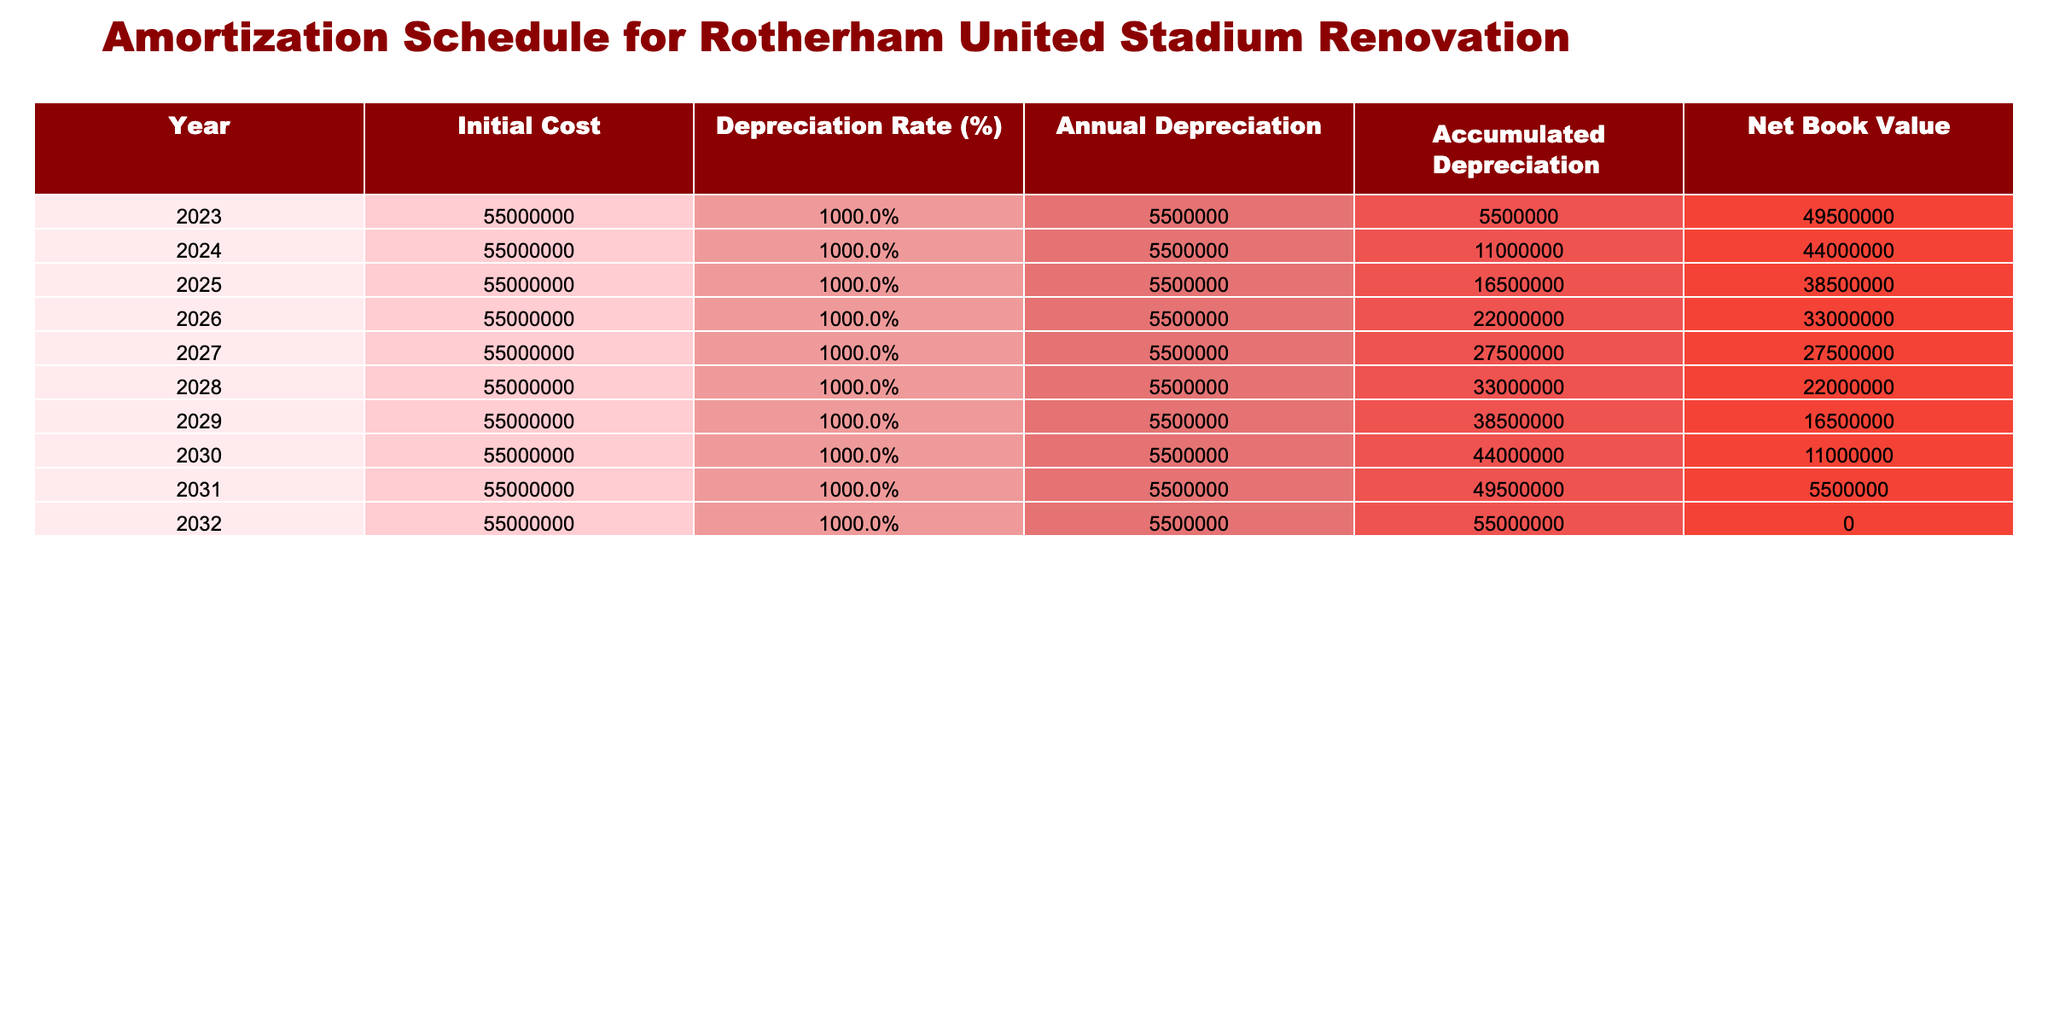What is the initial cost of the stadium renovation? The initial cost is specified in the first row of the table under "Initial Cost," which states £55,000,000.
Answer: £55,000,000 What is the accumulated depreciation in 2026? Looking at the "Accumulated Depreciation" column for the year 2026, the value listed is £22,000,000.
Answer: £22,000,000 In which year does the net book value of the stadium reach zero? The "Net Book Value" reaches zero in the year 2032, as seen in the last row of the table where it displays £0.
Answer: 2032 What is the total annual depreciation over the 10 years? To find the total annual depreciation, we sum the annual depreciation amounts for each year, which are all £5,500,000, resulting in £5,500,000 * 10 = £55,000,000.
Answer: £55,000,000 Is the annual depreciation consistent throughout the years? Yes, the annual depreciation is consistently £5,500,000 across all years.
Answer: Yes What is the net book value in 2028 compared to 2022? To determine this, we check the net book value for 2022, which is not explicitly listed but we can infer it is the same as the initial cost at £55,000,000. The net book value in 2028 is £22,000,000. Thus, it decreased from £55,000,000 to £22,000,000, which is a reduction of £33,000,000.
Answer: £22,000,000 What was the accumulated depreciation in 2025, and how much more was it in 2026? The accumulated depreciation in 2025 is £16,500,000, and in 2026, it is £22,000,000. The difference is £22,000,000 - £16,500,000 = £5,500,000.
Answer: £5,500,000 What percentage of the initial cost is the accumulated depreciation in 2030? The accumulated depreciation in 2030 is £44,000,000. To find the percentage of the initial cost, we calculate (£44,000,000 / £55,000,000) * 100 = 80%.
Answer: 80% In which year does the annual depreciation impact the net book value the most? The net book value decreases most in the year 2023 as it initially starts from £55,000,000 and reduces the most in this year to £49,500,000.
Answer: 2023 